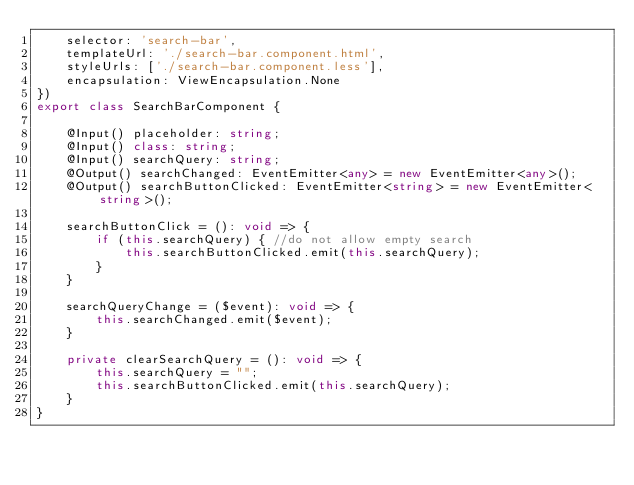<code> <loc_0><loc_0><loc_500><loc_500><_TypeScript_>    selector: 'search-bar',
    templateUrl: './search-bar.component.html',
    styleUrls: ['./search-bar.component.less'],
    encapsulation: ViewEncapsulation.None
})
export class SearchBarComponent {

    @Input() placeholder: string;
    @Input() class: string;
    @Input() searchQuery: string;
    @Output() searchChanged: EventEmitter<any> = new EventEmitter<any>();
    @Output() searchButtonClicked: EventEmitter<string> = new EventEmitter<string>();

    searchButtonClick = (): void => {
        if (this.searchQuery) { //do not allow empty search
            this.searchButtonClicked.emit(this.searchQuery);
        }
    }

    searchQueryChange = ($event): void => {
        this.searchChanged.emit($event);
    }

    private clearSearchQuery = (): void => {
        this.searchQuery = "";
        this.searchButtonClicked.emit(this.searchQuery);
    }
}

</code> 